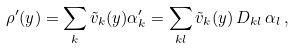<formula> <loc_0><loc_0><loc_500><loc_500>\rho ^ { \prime } ( y ) = \sum _ { k } \tilde { v } _ { k } ( y ) \alpha _ { k } ^ { \prime } = \sum _ { k l } \tilde { v } _ { k } ( y ) \, D _ { k l } \, \alpha _ { l } \, ,</formula> 